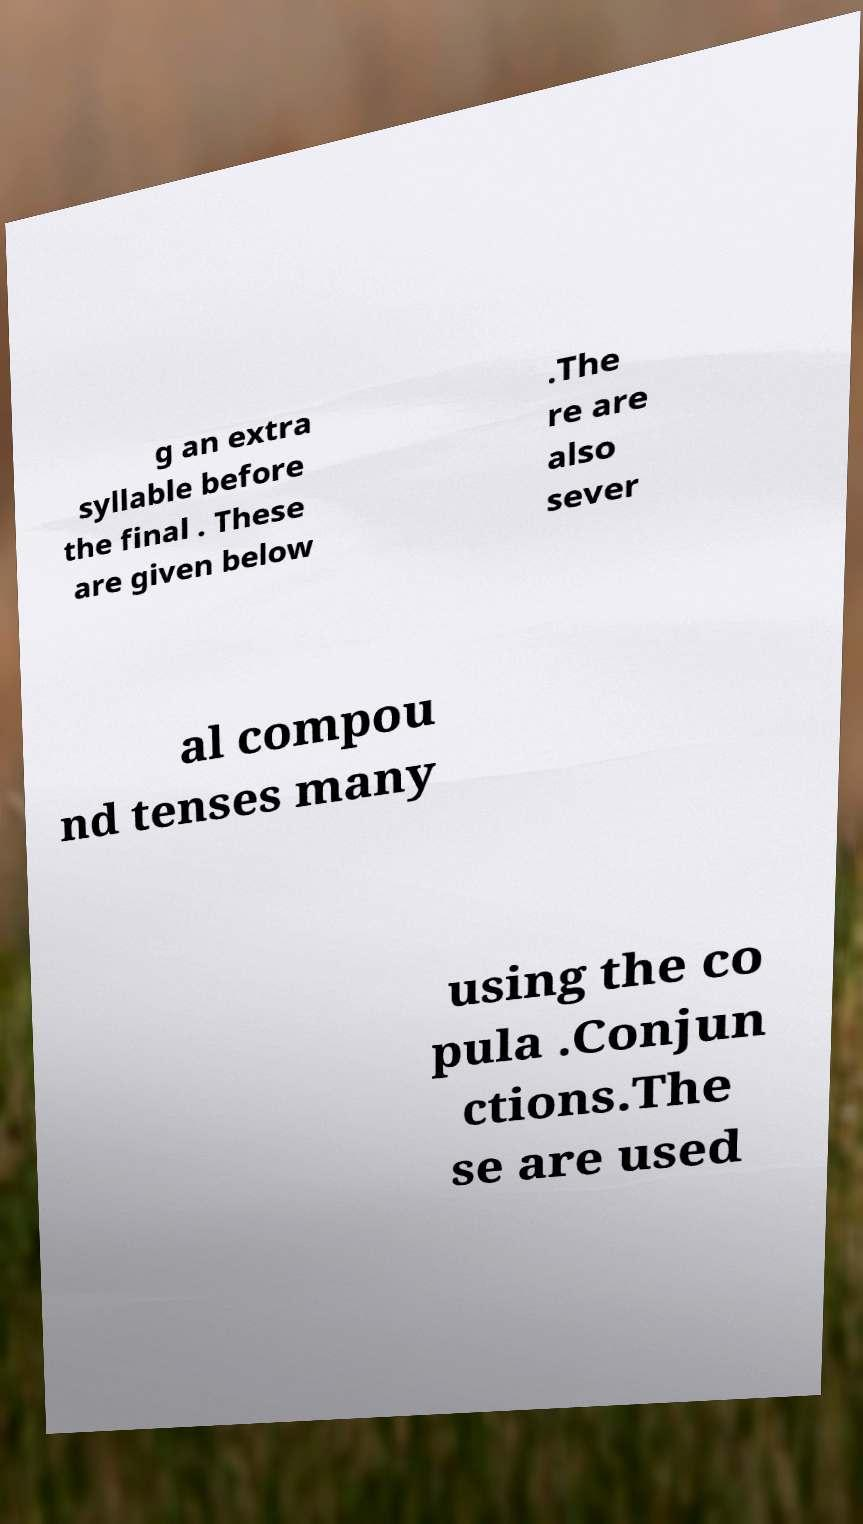Please identify and transcribe the text found in this image. g an extra syllable before the final . These are given below .The re are also sever al compou nd tenses many using the co pula .Conjun ctions.The se are used 